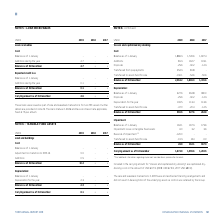According to Torm's financial document, Under reversal of impairment, where can additional information regarding impairment considerations be found? According to the financial document, refer to note 8. The relevant text states: "ation regarding impairment considerations, please refer to note 8. Included in the carrying amount for "Vessels and capitalized dry-docking" are capitalized dry- doc..." Also, What is included in the carrying amount for "Vessels and capitalized dry-docking"? Based on the financial document, the answer is capitalized drydocking costs. Also, What are the sub-elements under Vessels and capitalized dry-docking in the table? The document contains multiple relevant values: Cost, Depreciation, Impairment. From the document: "Impairment: Cost: Depreciation:..." Additionally, In which year was the impairment losses on tangible fixed assets the largest? According to the financial document, 2019. The relevant text states: "USDm 2019 2018 2017..." Also, can you calculate: What was the change in Additions in 2019 from 2018? Based on the calculation: 81.3-162.7, the result is -81.4 (in millions). This is based on the information: "Additions 81.3 162.7 103.1 Additions 81.3 162.7 103.1..." The key data points involved are: 162.7, 81.3. Also, can you calculate: What was the percentage change in Additions in 2019 from 2018? To answer this question, I need to perform calculations using the financial data. The calculation is: (81.3-162.7)/162.7, which equals -50.03 (percentage). This is based on the information: "Additions 81.3 162.7 103.1 Additions 81.3 162.7 103.1..." The key data points involved are: 162.7, 81.3. 